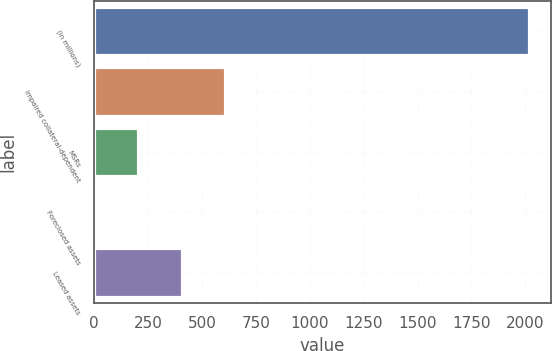Convert chart. <chart><loc_0><loc_0><loc_500><loc_500><bar_chart><fcel>(in millions)<fcel>Impaired collateral-dependent<fcel>MSRs<fcel>Foreclosed assets<fcel>Leased assets<nl><fcel>2016<fcel>606.9<fcel>204.3<fcel>3<fcel>405.6<nl></chart> 